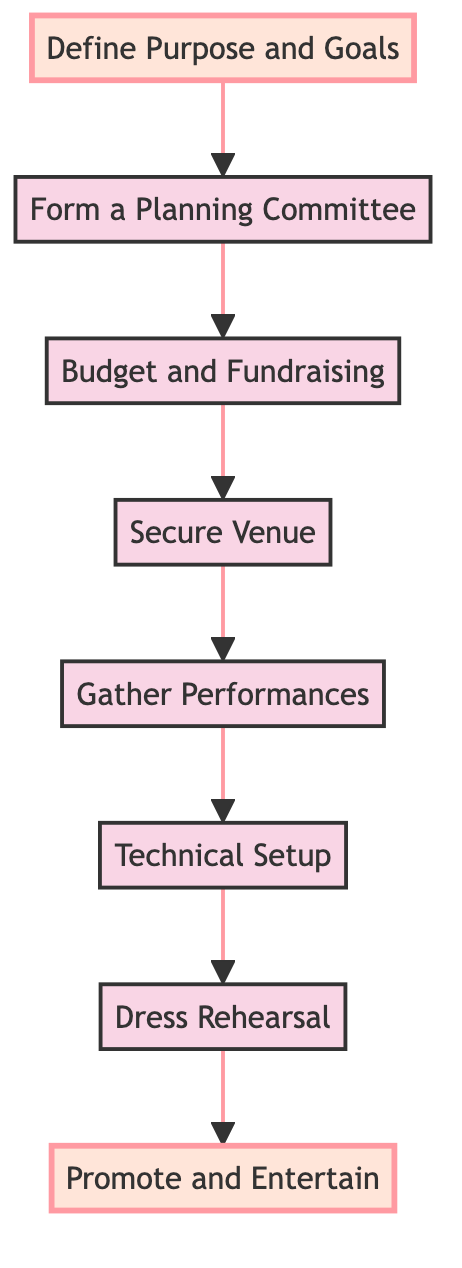What is the first step in the flow chart? The first step in the flow chart is at the bottom, which is "Define Purpose and Goals." It is the starting point of the instruction flow towards the final outcome.
Answer: Define Purpose and Goals How many steps are there in total? By counting each distinct node in the flow chart from the bottom to the top, we find there are eight steps listed.
Answer: Eight What is the last step before "Promote and Entertain"? The step right before "Promote and Entertain" is "Dress Rehearsal." It immediately precedes the final promotional activities in the flow.
Answer: Dress Rehearsal What two steps are connected directly by an arrow? The steps "Budget and Fundraising" and "Secure Venue" are directly connected, indicating a sequence in the planning process.
Answer: Budget and Fundraising, Secure Venue Which step involves gathering local talent? The step that involves gathering local talent is "Gather Performances." It focuses on inviting and auditioning performers for the show.
Answer: Gather Performances What is the connection between "Secure Venue" and "Gather Performances"? "Secure Venue" leads directly to "Gather Performances," indicating that securing the space is a prerequisite before inviting performers.
Answer: Secure Venue → Gather Performances Which step requires creating a budget plan? The step that requires creating a budget plan is "Budget and Fundraising." This step is crucial for understanding financial needs and securing funding.
Answer: Budget and Fundraising What is the relationship between the steps "Promote and Entertain" and "Dress Rehearsal"? "Dress Rehearsal" precedes "Promote and Entertain," meaning rehearsing the show occurs before promoting it to the audience.
Answer: Dress Rehearsal → Promote and Entertain 